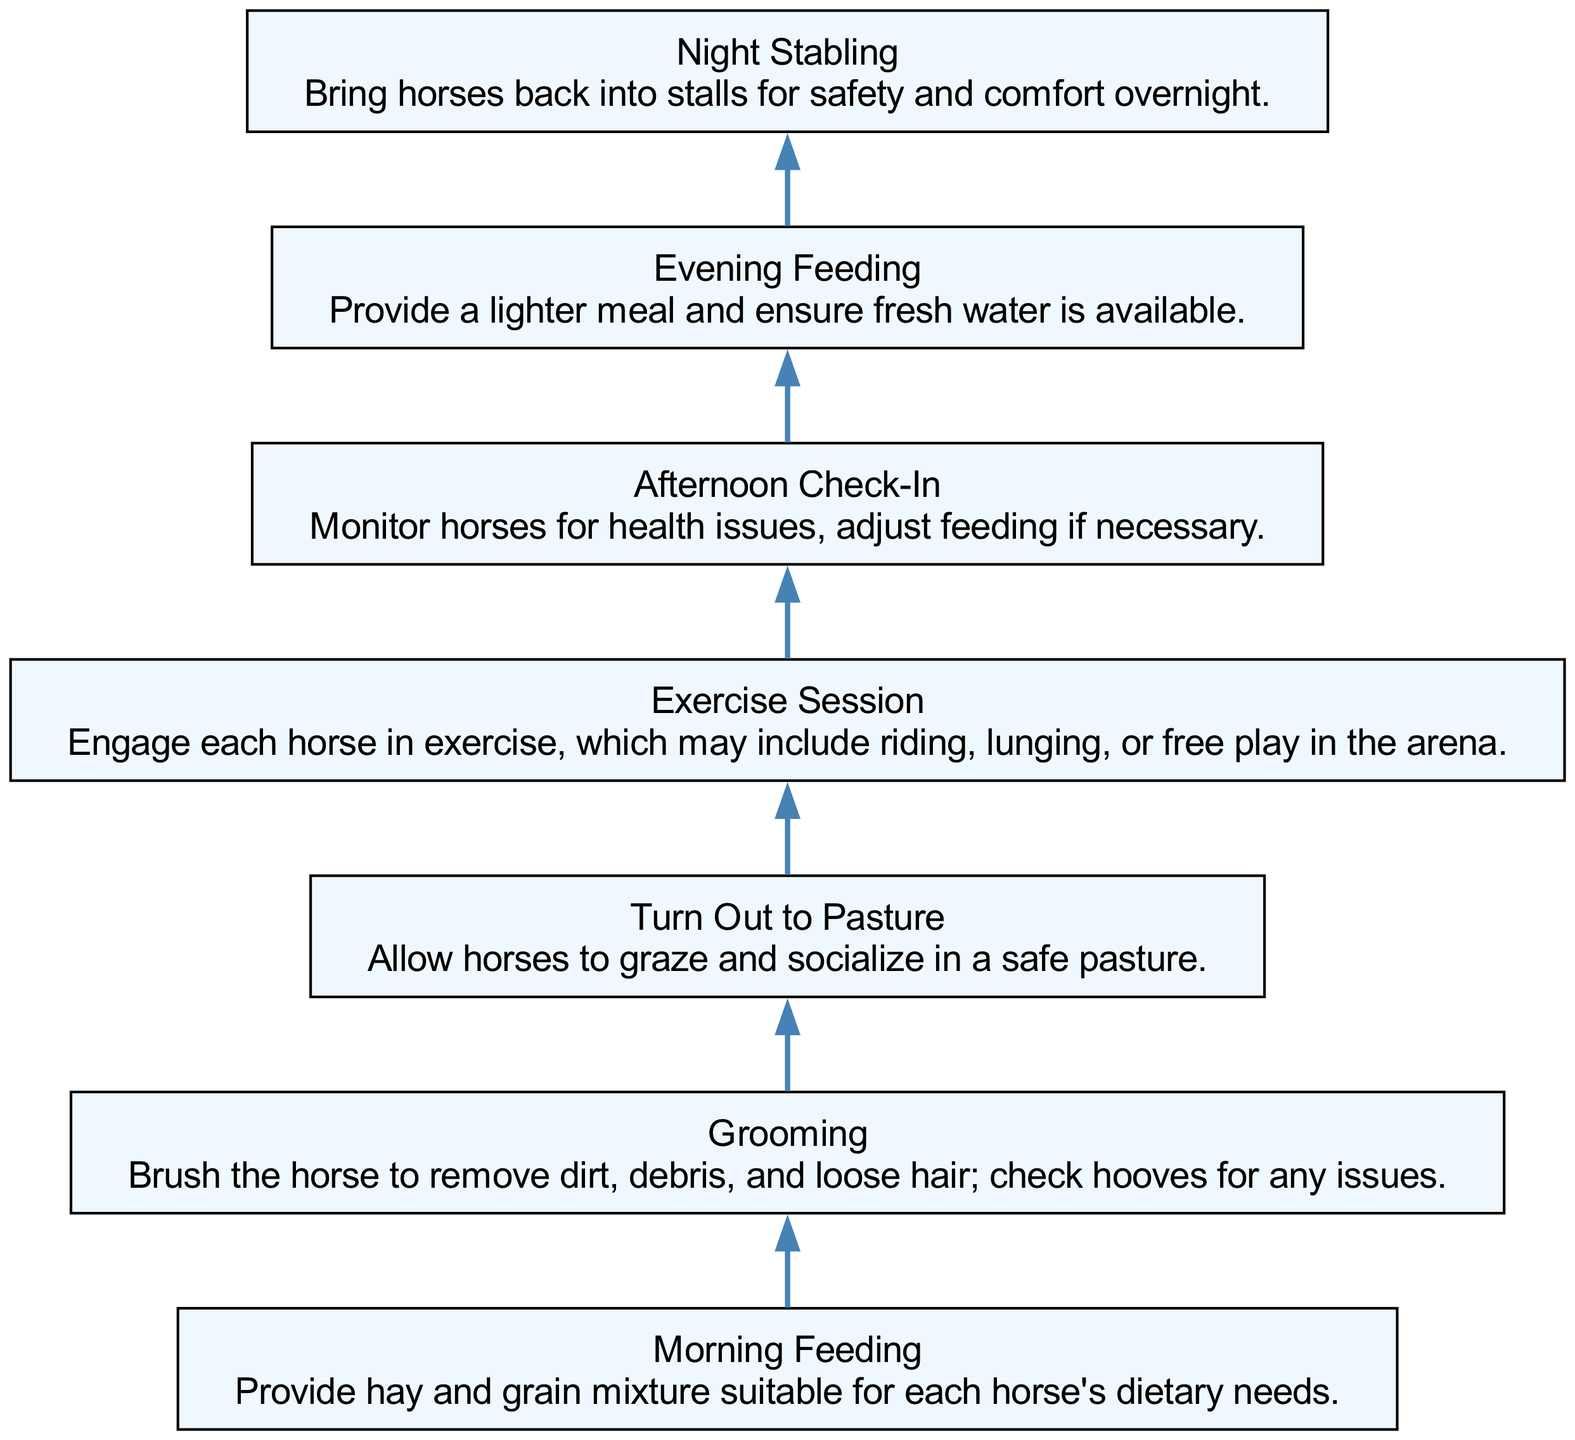What is the first task in the diagram? The diagram begins with "Morning Feeding," as it is the first element listed and shown at the bottom of the flow chart.
Answer: Morning Feeding How many total tasks are in the routine? There are a total of seven tasks represented in the flow chart, as indicated by the seven nodes present in the diagram.
Answer: 7 What follows "Evening Feeding" in the routine? The task that follows "Evening Feeding" is "Night Stabling," which is the next node in the flow from the evening feeding task.
Answer: Night Stabling What is the main purpose of the "Grooming" task? The purpose of the "Grooming" task is to brush the horse, remove dirt and debris, and check hooves, as described in its details.
Answer: To remove dirt and check hooves Which task allows horses to graze? "Turn Out to Pasture" is the task that allows horses to graze and socialize in a safe pasture, according to the description in the diagram.
Answer: Turn Out to Pasture What is the last task listed in the diagram? The last task in the diagram is "Night Stabling," as it is the final node in the bottom-up arrangement of tasks.
Answer: Night Stabling What tasks are mentioned in the flow before "Afternoon Check-In"? The tasks that occur before "Afternoon Check-In" are "Morning Feeding," "Grooming," "Turn Out to Pasture," and "Exercise Session," which precede it sequentially in the flow.
Answer: Morning Feeding, Grooming, Turn Out to Pasture, Exercise Session How does the "Exercise Session" relate to the overall routine? The "Exercise Session" is positioned after the horses are turned out to pasture, indicating that horses engage in designated exercise following their outdoor time.
Answer: It's after Turn Out to Pasture What is the significance of the "Evening Feeding" task? "Evening Feeding" provides a lighter meal and ensures fresh water for the horses, showing its role in their daily care routine to maintain hydration and nutrition.
Answer: To provide a lighter meal and fresh water 